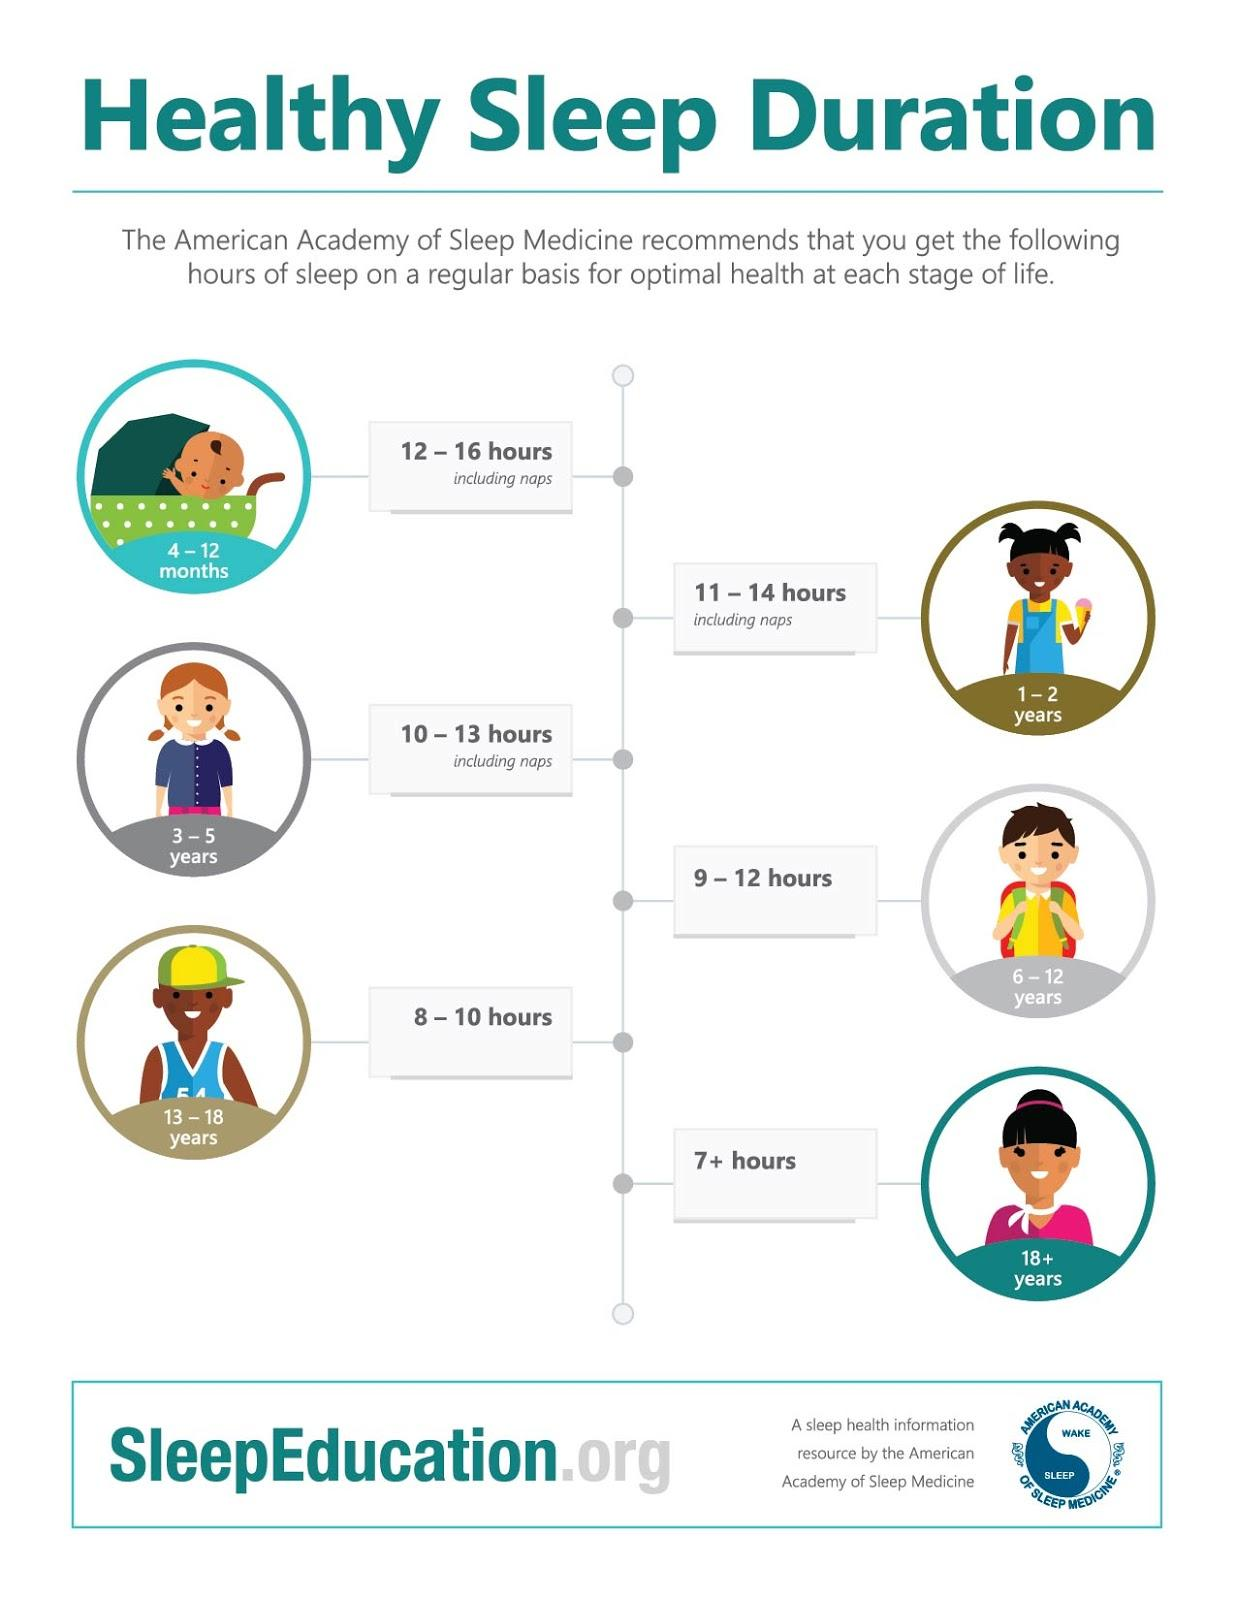Indicate a few pertinent items in this graphic. According to the recommended sleep hours for age groups, 1-2 year-olds should receive 11-14 hours of sleep, while 3-5 year-olds, 4-12 months, and 3-4 years should receive 10-13 hours, 9-11 hours, and 10-13 hours of sleep, respectively. According to studies, 13-18 year old individuals should aim to get 8-10 hours of sleep each night. However, the optimal sleep duration for this age group may vary and depends on various factors such as age, gender, and lifestyle. Some sources suggest that 9-12 hours of sleep per night may be sufficient for teenagers, while others recommend 7+ hours of sleep as the minimum amount of sleep required for optimal health and development. Regardless of the specific sleep duration recommended, it is important for teenagers to prioritize getting enough restful sleep each night to support their physical and mental well-being. 